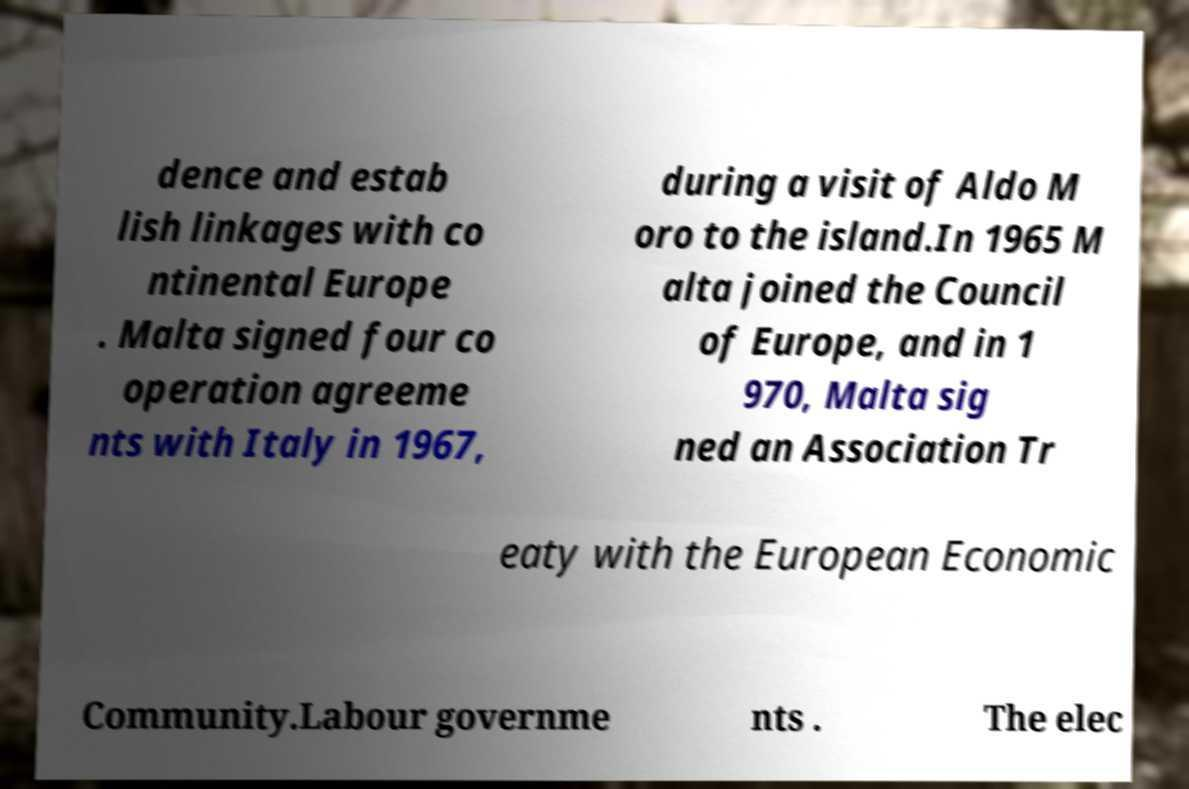Can you read and provide the text displayed in the image?This photo seems to have some interesting text. Can you extract and type it out for me? dence and estab lish linkages with co ntinental Europe . Malta signed four co operation agreeme nts with Italy in 1967, during a visit of Aldo M oro to the island.In 1965 M alta joined the Council of Europe, and in 1 970, Malta sig ned an Association Tr eaty with the European Economic Community.Labour governme nts . The elec 